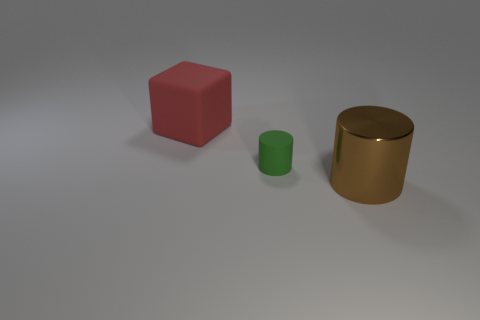How many other things are made of the same material as the tiny green object?
Give a very brief answer. 1. Is the size of the cylinder that is left of the large brown metal thing the same as the rubber object that is left of the matte cylinder?
Provide a succinct answer. No. What number of things are either things that are to the right of the red matte object or brown things that are right of the small green cylinder?
Keep it short and to the point. 2. Are there any other things that have the same shape as the tiny matte thing?
Your response must be concise. Yes. Is the color of the cylinder behind the big metal cylinder the same as the large thing that is right of the rubber cube?
Your answer should be compact. No. How many rubber things are either small cyan cubes or large red objects?
Offer a terse response. 1. Is there anything else that is the same size as the shiny thing?
Your response must be concise. Yes. The big object in front of the large object on the left side of the brown shiny object is what shape?
Give a very brief answer. Cylinder. Do the large thing right of the large matte cube and the cylinder that is behind the big metallic cylinder have the same material?
Your response must be concise. No. There is a large object on the right side of the green rubber cylinder; how many big cylinders are behind it?
Keep it short and to the point. 0. 